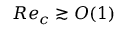Convert formula to latex. <formula><loc_0><loc_0><loc_500><loc_500>R e _ { c } \gtrsim O ( 1 )</formula> 